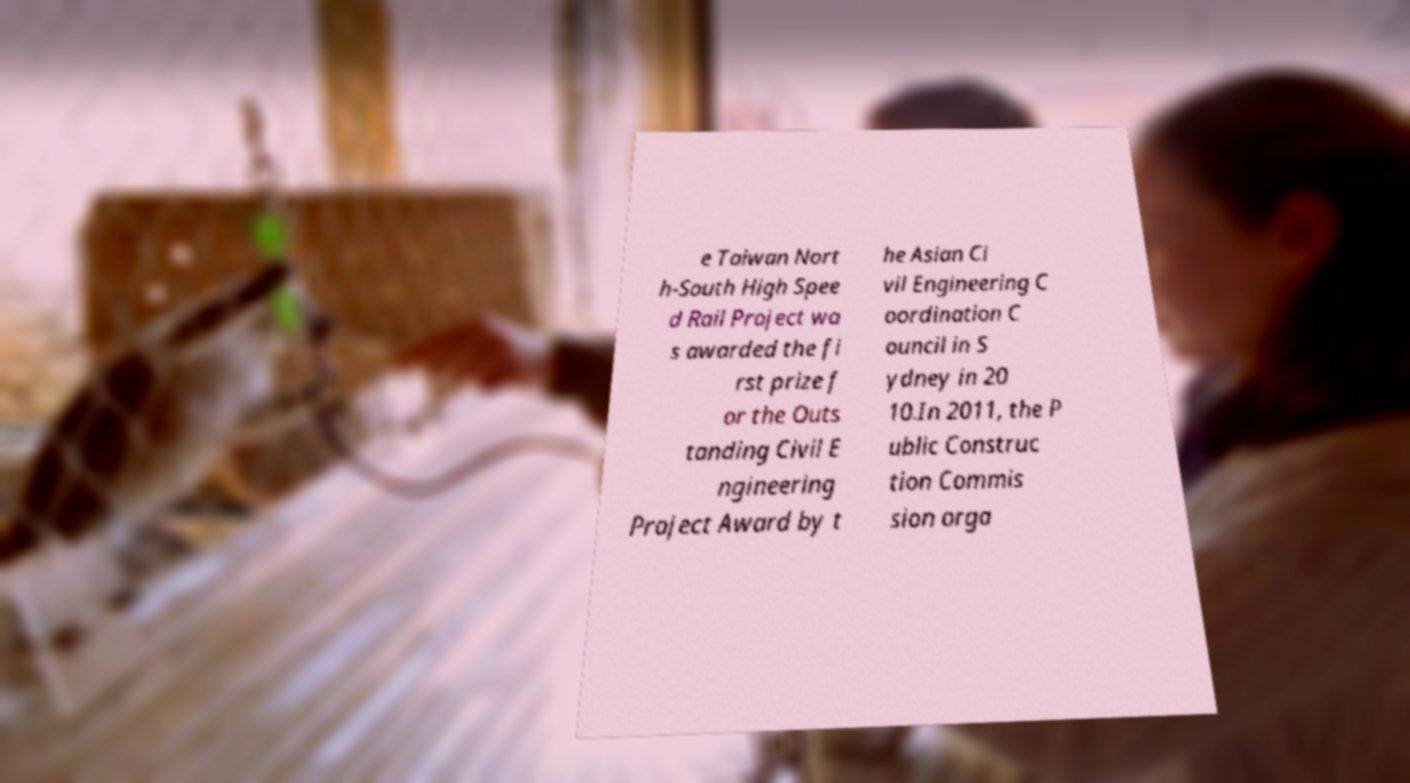Please read and relay the text visible in this image. What does it say? e Taiwan Nort h-South High Spee d Rail Project wa s awarded the fi rst prize f or the Outs tanding Civil E ngineering Project Award by t he Asian Ci vil Engineering C oordination C ouncil in S ydney in 20 10.In 2011, the P ublic Construc tion Commis sion orga 